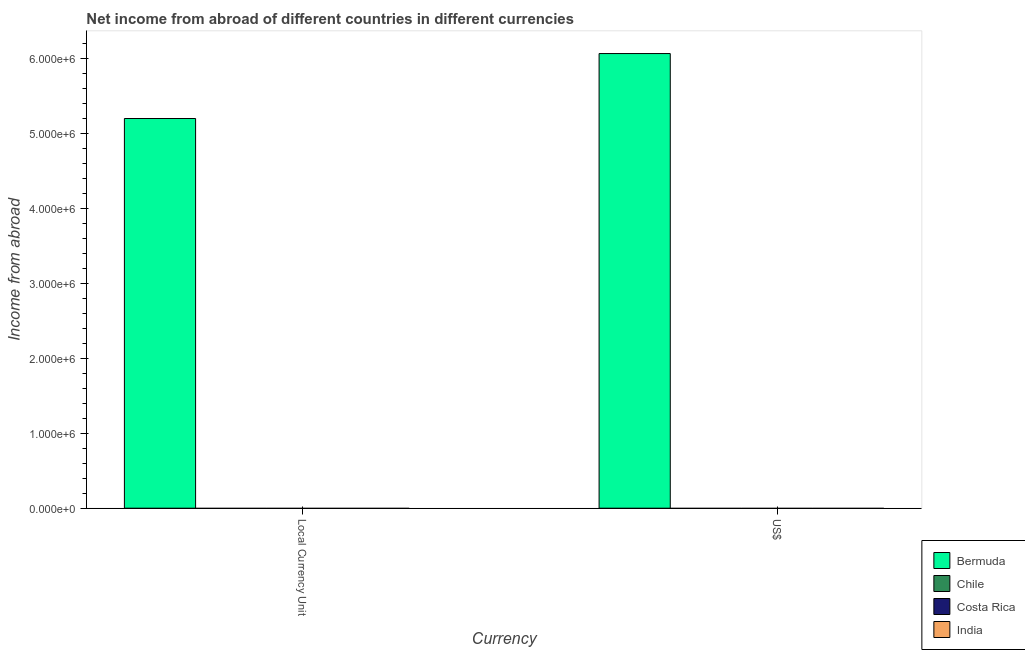How many different coloured bars are there?
Offer a terse response. 1. How many bars are there on the 1st tick from the left?
Your answer should be compact. 1. How many bars are there on the 2nd tick from the right?
Ensure brevity in your answer.  1. What is the label of the 1st group of bars from the left?
Your response must be concise. Local Currency Unit. What is the income from abroad in constant 2005 us$ in Chile?
Provide a short and direct response. 0. Across all countries, what is the maximum income from abroad in constant 2005 us$?
Offer a very short reply. 5.20e+06. In which country was the income from abroad in us$ maximum?
Provide a succinct answer. Bermuda. What is the total income from abroad in constant 2005 us$ in the graph?
Ensure brevity in your answer.  5.20e+06. What is the difference between the income from abroad in us$ in India and the income from abroad in constant 2005 us$ in Bermuda?
Provide a short and direct response. -5.20e+06. What is the average income from abroad in us$ per country?
Give a very brief answer. 1.52e+06. What is the difference between the income from abroad in us$ and income from abroad in constant 2005 us$ in Bermuda?
Keep it short and to the point. 8.67e+05. In how many countries, is the income from abroad in us$ greater than 4200000 units?
Provide a short and direct response. 1. Are all the bars in the graph horizontal?
Provide a succinct answer. No. How many countries are there in the graph?
Provide a succinct answer. 4. What is the difference between two consecutive major ticks on the Y-axis?
Keep it short and to the point. 1.00e+06. Are the values on the major ticks of Y-axis written in scientific E-notation?
Make the answer very short. Yes. Where does the legend appear in the graph?
Your response must be concise. Bottom right. How many legend labels are there?
Provide a short and direct response. 4. How are the legend labels stacked?
Provide a succinct answer. Vertical. What is the title of the graph?
Keep it short and to the point. Net income from abroad of different countries in different currencies. Does "St. Martin (French part)" appear as one of the legend labels in the graph?
Ensure brevity in your answer.  No. What is the label or title of the X-axis?
Keep it short and to the point. Currency. What is the label or title of the Y-axis?
Offer a very short reply. Income from abroad. What is the Income from abroad in Bermuda in Local Currency Unit?
Your answer should be very brief. 5.20e+06. What is the Income from abroad in Chile in Local Currency Unit?
Ensure brevity in your answer.  0. What is the Income from abroad of India in Local Currency Unit?
Your response must be concise. 0. What is the Income from abroad of Bermuda in US$?
Your response must be concise. 6.07e+06. What is the Income from abroad in Costa Rica in US$?
Provide a succinct answer. 0. Across all Currency, what is the maximum Income from abroad of Bermuda?
Offer a terse response. 6.07e+06. Across all Currency, what is the minimum Income from abroad in Bermuda?
Offer a terse response. 5.20e+06. What is the total Income from abroad in Bermuda in the graph?
Offer a very short reply. 1.13e+07. What is the total Income from abroad of Costa Rica in the graph?
Keep it short and to the point. 0. What is the total Income from abroad of India in the graph?
Give a very brief answer. 0. What is the difference between the Income from abroad of Bermuda in Local Currency Unit and that in US$?
Provide a succinct answer. -8.67e+05. What is the average Income from abroad of Bermuda per Currency?
Offer a very short reply. 5.63e+06. What is the average Income from abroad in Chile per Currency?
Provide a succinct answer. 0. What is the average Income from abroad of Costa Rica per Currency?
Offer a terse response. 0. What is the average Income from abroad of India per Currency?
Provide a succinct answer. 0. What is the difference between the highest and the second highest Income from abroad in Bermuda?
Make the answer very short. 8.67e+05. What is the difference between the highest and the lowest Income from abroad in Bermuda?
Keep it short and to the point. 8.67e+05. 